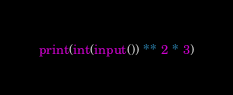<code> <loc_0><loc_0><loc_500><loc_500><_Python_>print(int(input()) ** 2 * 3)</code> 